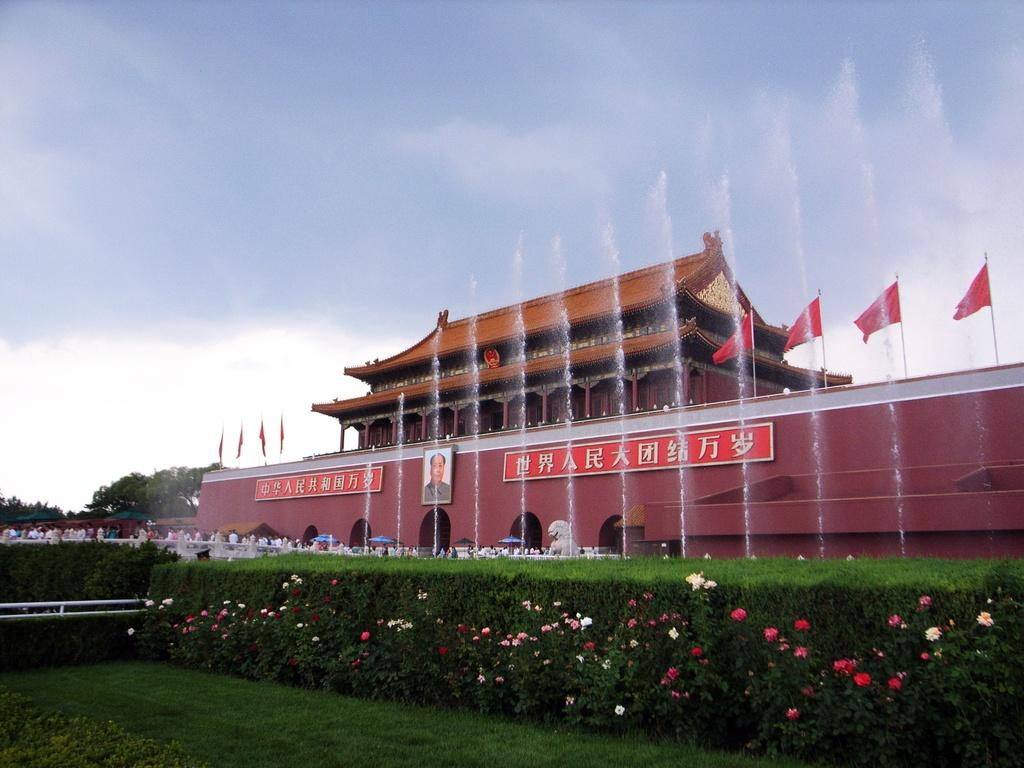What types of vegetation can be seen at the bottom of the image? There are plants, flowers, and grass at the bottom of the image. What can be found in the middle of the image? There are people, flags, water fountains, a building, trees, a photo frame, boards, and text in the middle of the image. How many different elements are present in the middle of the image? There are at least 9 different elements present in the middle of the image. What is visible in the background of the image? Sky is visible in the background of the image. What can be seen in the sky? Clouds can be seen in the sky. How many screws can be seen holding the bike together in the image? There is no bike present in the image, so it is not possible to determine the number of screws holding it together. 